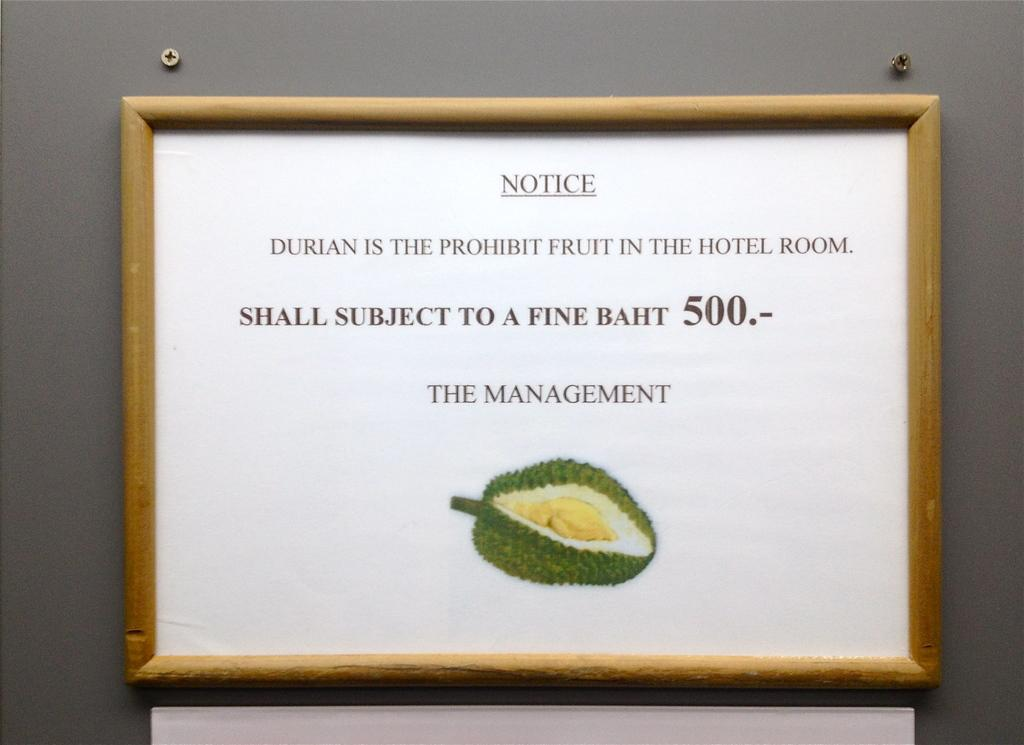<image>
Create a compact narrative representing the image presented. Framed picture with NOTICE DURIAN IS THE PROHIBIT FRUIT IN HOTEL ROOM with fine of 500 for failing to comply with management and an image of fruit. 